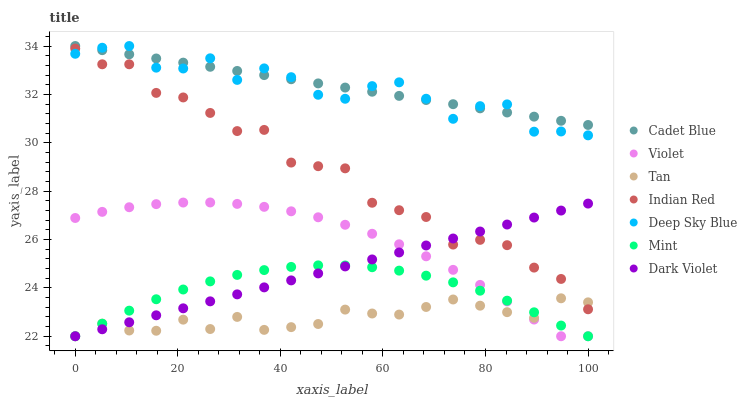Does Tan have the minimum area under the curve?
Answer yes or no. Yes. Does Cadet Blue have the maximum area under the curve?
Answer yes or no. Yes. Does Indian Red have the minimum area under the curve?
Answer yes or no. No. Does Indian Red have the maximum area under the curve?
Answer yes or no. No. Is Dark Violet the smoothest?
Answer yes or no. Yes. Is Indian Red the roughest?
Answer yes or no. Yes. Is Indian Red the smoothest?
Answer yes or no. No. Is Dark Violet the roughest?
Answer yes or no. No. Does Dark Violet have the lowest value?
Answer yes or no. Yes. Does Indian Red have the lowest value?
Answer yes or no. No. Does Deep Sky Blue have the highest value?
Answer yes or no. Yes. Does Indian Red have the highest value?
Answer yes or no. No. Is Mint less than Deep Sky Blue?
Answer yes or no. Yes. Is Deep Sky Blue greater than Mint?
Answer yes or no. Yes. Does Dark Violet intersect Mint?
Answer yes or no. Yes. Is Dark Violet less than Mint?
Answer yes or no. No. Is Dark Violet greater than Mint?
Answer yes or no. No. Does Mint intersect Deep Sky Blue?
Answer yes or no. No. 